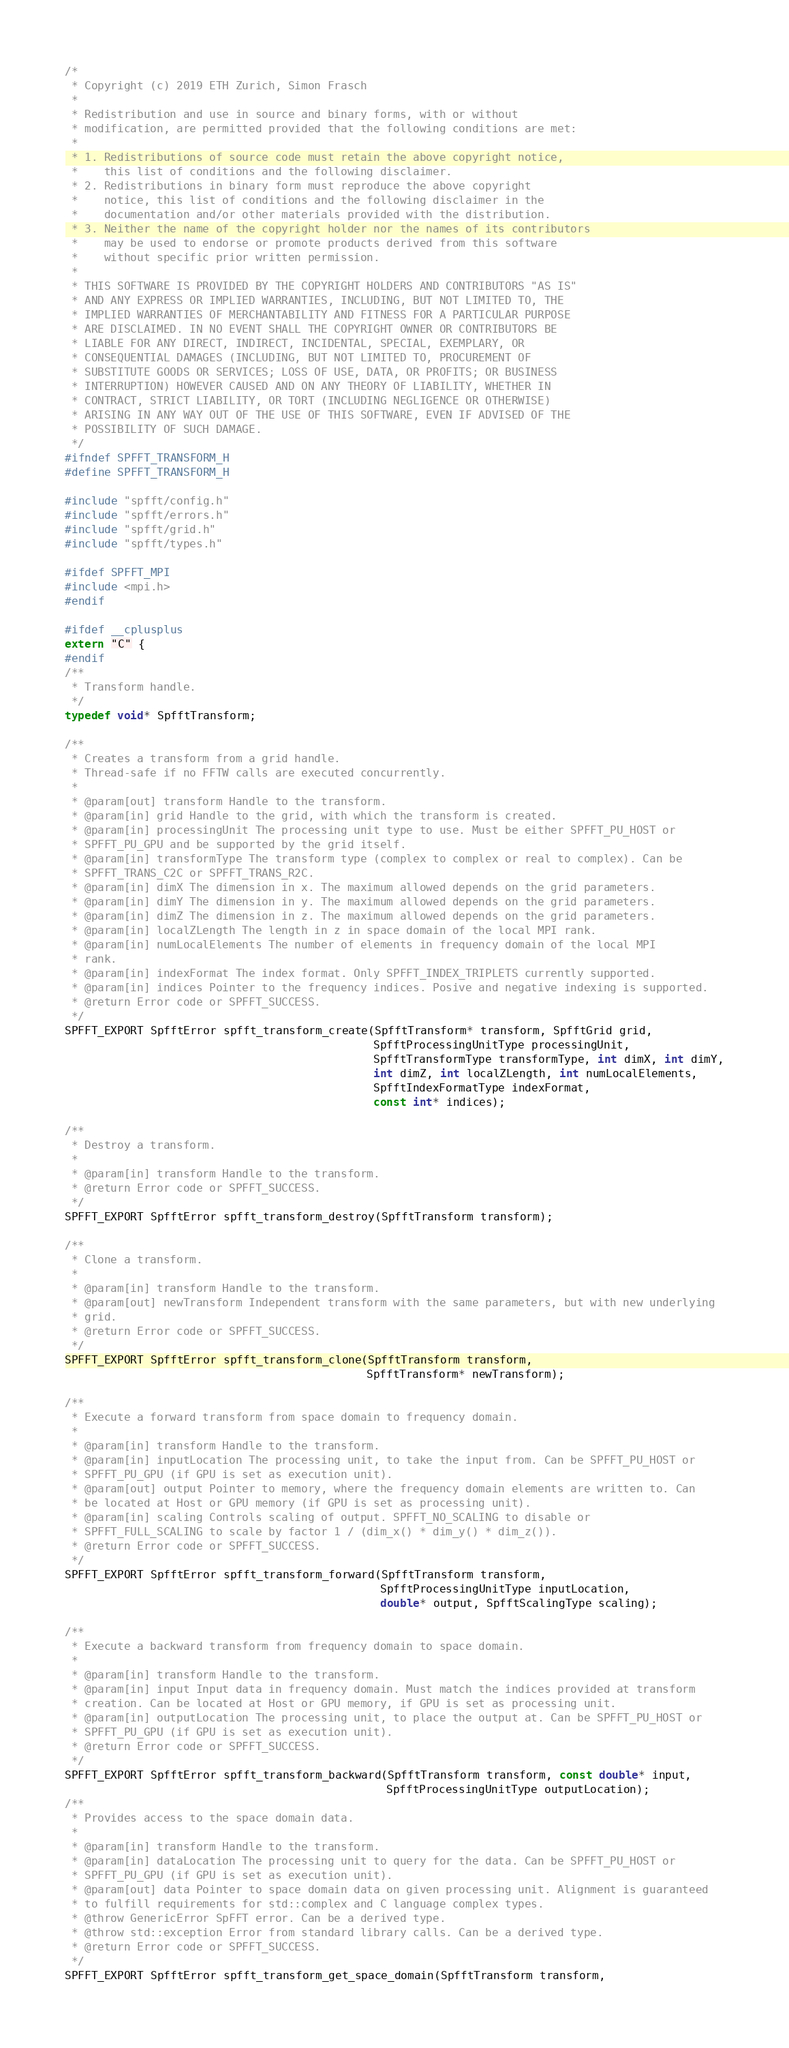Convert code to text. <code><loc_0><loc_0><loc_500><loc_500><_C_>/*
 * Copyright (c) 2019 ETH Zurich, Simon Frasch
 *
 * Redistribution and use in source and binary forms, with or without
 * modification, are permitted provided that the following conditions are met:
 *
 * 1. Redistributions of source code must retain the above copyright notice,
 *    this list of conditions and the following disclaimer.
 * 2. Redistributions in binary form must reproduce the above copyright
 *    notice, this list of conditions and the following disclaimer in the
 *    documentation and/or other materials provided with the distribution.
 * 3. Neither the name of the copyright holder nor the names of its contributors
 *    may be used to endorse or promote products derived from this software
 *    without specific prior written permission.
 *
 * THIS SOFTWARE IS PROVIDED BY THE COPYRIGHT HOLDERS AND CONTRIBUTORS "AS IS"
 * AND ANY EXPRESS OR IMPLIED WARRANTIES, INCLUDING, BUT NOT LIMITED TO, THE
 * IMPLIED WARRANTIES OF MERCHANTABILITY AND FITNESS FOR A PARTICULAR PURPOSE
 * ARE DISCLAIMED. IN NO EVENT SHALL THE COPYRIGHT OWNER OR CONTRIBUTORS BE
 * LIABLE FOR ANY DIRECT, INDIRECT, INCIDENTAL, SPECIAL, EXEMPLARY, OR
 * CONSEQUENTIAL DAMAGES (INCLUDING, BUT NOT LIMITED TO, PROCUREMENT OF
 * SUBSTITUTE GOODS OR SERVICES; LOSS OF USE, DATA, OR PROFITS; OR BUSINESS
 * INTERRUPTION) HOWEVER CAUSED AND ON ANY THEORY OF LIABILITY, WHETHER IN
 * CONTRACT, STRICT LIABILITY, OR TORT (INCLUDING NEGLIGENCE OR OTHERWISE)
 * ARISING IN ANY WAY OUT OF THE USE OF THIS SOFTWARE, EVEN IF ADVISED OF THE
 * POSSIBILITY OF SUCH DAMAGE.
 */
#ifndef SPFFT_TRANSFORM_H
#define SPFFT_TRANSFORM_H

#include "spfft/config.h"
#include "spfft/errors.h"
#include "spfft/grid.h"
#include "spfft/types.h"

#ifdef SPFFT_MPI
#include <mpi.h>
#endif

#ifdef __cplusplus
extern "C" {
#endif
/**
 * Transform handle.
 */
typedef void* SpfftTransform;

/**
 * Creates a transform from a grid handle.
 * Thread-safe if no FFTW calls are executed concurrently.
 *
 * @param[out] transform Handle to the transform.
 * @param[in] grid Handle to the grid, with which the transform is created.
 * @param[in] processingUnit The processing unit type to use. Must be either SPFFT_PU_HOST or
 * SPFFT_PU_GPU and be supported by the grid itself.
 * @param[in] transformType The transform type (complex to complex or real to complex). Can be
 * SPFFT_TRANS_C2C or SPFFT_TRANS_R2C.
 * @param[in] dimX The dimension in x. The maximum allowed depends on the grid parameters.
 * @param[in] dimY The dimension in y. The maximum allowed depends on the grid parameters.
 * @param[in] dimZ The dimension in z. The maximum allowed depends on the grid parameters.
 * @param[in] localZLength The length in z in space domain of the local MPI rank.
 * @param[in] numLocalElements The number of elements in frequency domain of the local MPI
 * rank.
 * @param[in] indexFormat The index format. Only SPFFT_INDEX_TRIPLETS currently supported.
 * @param[in] indices Pointer to the frequency indices. Posive and negative indexing is supported.
 * @return Error code or SPFFT_SUCCESS.
 */
SPFFT_EXPORT SpfftError spfft_transform_create(SpfftTransform* transform, SpfftGrid grid,
                                               SpfftProcessingUnitType processingUnit,
                                               SpfftTransformType transformType, int dimX, int dimY,
                                               int dimZ, int localZLength, int numLocalElements,
                                               SpfftIndexFormatType indexFormat,
                                               const int* indices);

/**
 * Destroy a transform.
 *
 * @param[in] transform Handle to the transform.
 * @return Error code or SPFFT_SUCCESS.
 */
SPFFT_EXPORT SpfftError spfft_transform_destroy(SpfftTransform transform);

/**
 * Clone a transform.
 *
 * @param[in] transform Handle to the transform.
 * @param[out] newTransform Independent transform with the same parameters, but with new underlying
 * grid.
 * @return Error code or SPFFT_SUCCESS.
 */
SPFFT_EXPORT SpfftError spfft_transform_clone(SpfftTransform transform,
                                              SpfftTransform* newTransform);

/**
 * Execute a forward transform from space domain to frequency domain.
 *
 * @param[in] transform Handle to the transform.
 * @param[in] inputLocation The processing unit, to take the input from. Can be SPFFT_PU_HOST or
 * SPFFT_PU_GPU (if GPU is set as execution unit).
 * @param[out] output Pointer to memory, where the frequency domain elements are written to. Can
 * be located at Host or GPU memory (if GPU is set as processing unit).
 * @param[in] scaling Controls scaling of output. SPFFT_NO_SCALING to disable or
 * SPFFT_FULL_SCALING to scale by factor 1 / (dim_x() * dim_y() * dim_z()).
 * @return Error code or SPFFT_SUCCESS.
 */
SPFFT_EXPORT SpfftError spfft_transform_forward(SpfftTransform transform,
                                                SpfftProcessingUnitType inputLocation,
                                                double* output, SpfftScalingType scaling);

/**
 * Execute a backward transform from frequency domain to space domain.
 *
 * @param[in] transform Handle to the transform.
 * @param[in] input Input data in frequency domain. Must match the indices provided at transform
 * creation. Can be located at Host or GPU memory, if GPU is set as processing unit.
 * @param[in] outputLocation The processing unit, to place the output at. Can be SPFFT_PU_HOST or
 * SPFFT_PU_GPU (if GPU is set as execution unit).
 * @return Error code or SPFFT_SUCCESS.
 */
SPFFT_EXPORT SpfftError spfft_transform_backward(SpfftTransform transform, const double* input,
                                                 SpfftProcessingUnitType outputLocation);
/**
 * Provides access to the space domain data.
 *
 * @param[in] transform Handle to the transform.
 * @param[in] dataLocation The processing unit to query for the data. Can be SPFFT_PU_HOST or
 * SPFFT_PU_GPU (if GPU is set as execution unit).
 * @param[out] data Pointer to space domain data on given processing unit. Alignment is guaranteed
 * to fulfill requirements for std::complex and C language complex types.
 * @throw GenericError SpFFT error. Can be a derived type.
 * @throw std::exception Error from standard library calls. Can be a derived type.
 * @return Error code or SPFFT_SUCCESS.
 */
SPFFT_EXPORT SpfftError spfft_transform_get_space_domain(SpfftTransform transform,</code> 